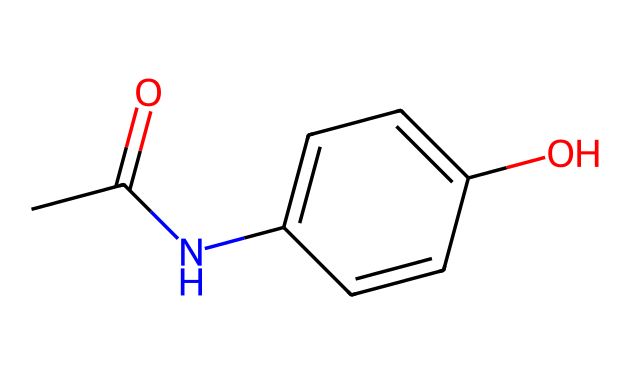What is the molecular formula of acetaminophen? To determine the molecular formula from the SMILES, count each type of atom. The 'C' represents carbon, 'O' represents oxygen, and 'N' represents nitrogen. In the SMILES CC(=O)NC1=CC=C(C=C1)O, there are 8 carbon atoms, 9 hydrogen atoms, 1 nitrogen atom, and 2 oxygen atoms, which gives the formula C8H9NO2.
Answer: C8H9NO2 How many rings are present in the chemical structure? In the given SMILES, the 'C1' indicates the start of a ring and is closed by another 'C1' later in the structure. Counting these, there is one ring present in the structure of acetaminophen.
Answer: 1 What functional groups are present in acetaminophen? By analyzing the structure, we can identify the functional groups. The 'CC(=O)' indicates an acetyl group (carbonyl) and the 'NH' indicates an amine. The 'OH' at the end denotes a hydroxyl functional group. Therefore, acetaminophen contains an amide and a phenol group.
Answer: amide, phenol Which atom is responsible for the analgesic properties of acetaminophen? The analgesic properties are primarily attributed to the nitrogen atom in the amide functional group, which plays a crucial role in the drug's mechanism of action in pain relief.
Answer: nitrogen What is the total number of hydrogen atoms in the structure? To find the total number of hydrogen atoms, we can look at each atom type in the SMILES. Each carbon typically has 4 bonds, so we account for the number of hydrogen atoms each carbon can bond with. There are 9 hydrogen atoms identified in the molecular structure of acetaminophen.
Answer: 9 What type of isomerism can acetaminophen exhibit? Given its structure, acetaminophen can exhibit stereoisomerism due to the presence of carbon atoms that may have different spatial arrangements. However, it is primarily a structural isomer with no stereocenters. Thus, it primarily shows structural isomerism.
Answer: structural isomerism 